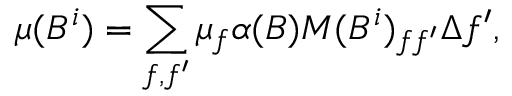<formula> <loc_0><loc_0><loc_500><loc_500>\mu ( B ^ { i } ) = \sum _ { f , f ^ { \prime } } \mu _ { f } \alpha ( B ) M ( B ^ { i } ) _ { f f ^ { \prime } } \Delta f ^ { \prime } ,</formula> 